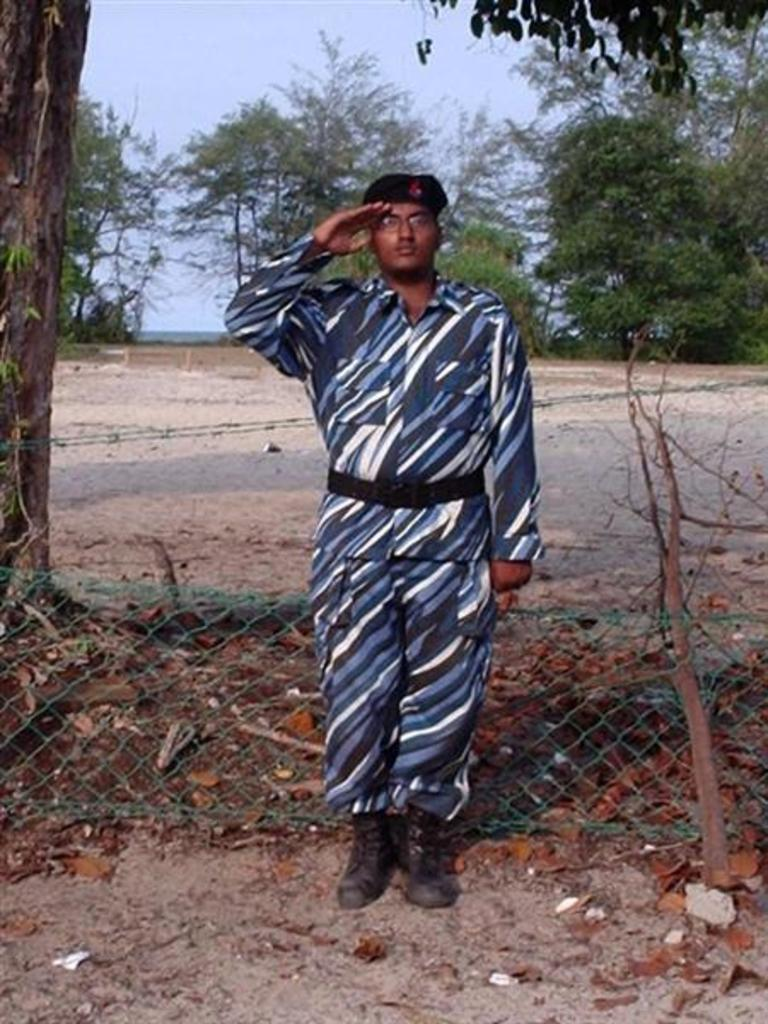What is the main subject of the image? There is a man standing in the middle of the image. What is located behind the man? There is a fencing behind the man. What type of natural elements can be seen in the image? Trees are visible in the image. What part of the sky can be seen in the image? The sky is visible in the top left side of the image. What type of badge is the man wearing in the image? There is no badge visible on the man in the image. What thrilling activity is the man participating in the image? The image does not depict any specific activity, so it cannot be determined if it is thrilling or not. 